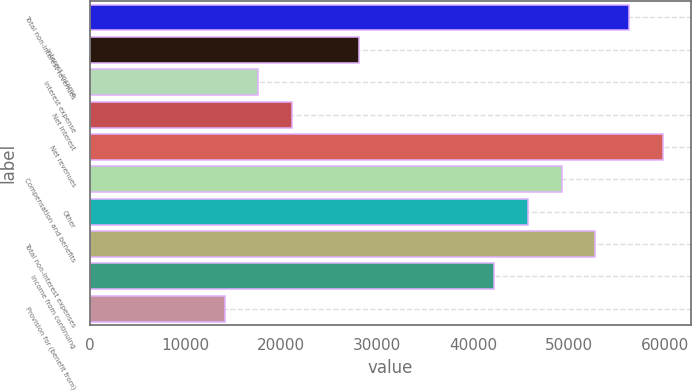Convert chart. <chart><loc_0><loc_0><loc_500><loc_500><bar_chart><fcel>Total non-interest revenues<fcel>Interest income<fcel>Interest expense<fcel>Net interest<fcel>Net revenues<fcel>Compensation and benefits<fcel>Other<fcel>Total non-interest expenses<fcel>Income from continuing<fcel>Provision for (benefit from)<nl><fcel>56238.4<fcel>28127.2<fcel>17585.5<fcel>21099.4<fcel>59752.3<fcel>49210.6<fcel>45696.7<fcel>52724.5<fcel>42182.8<fcel>14071.6<nl></chart> 